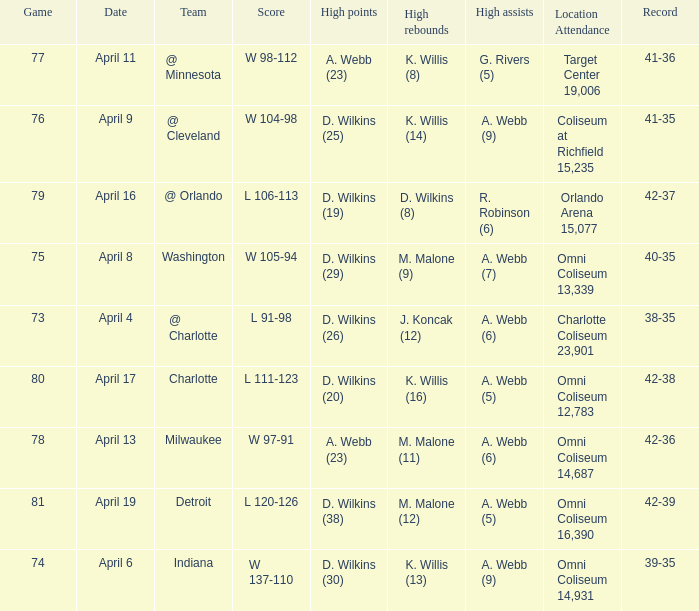What was the location and attendance when d. wilkins (29) had the high points? Omni Coliseum 13,339. 